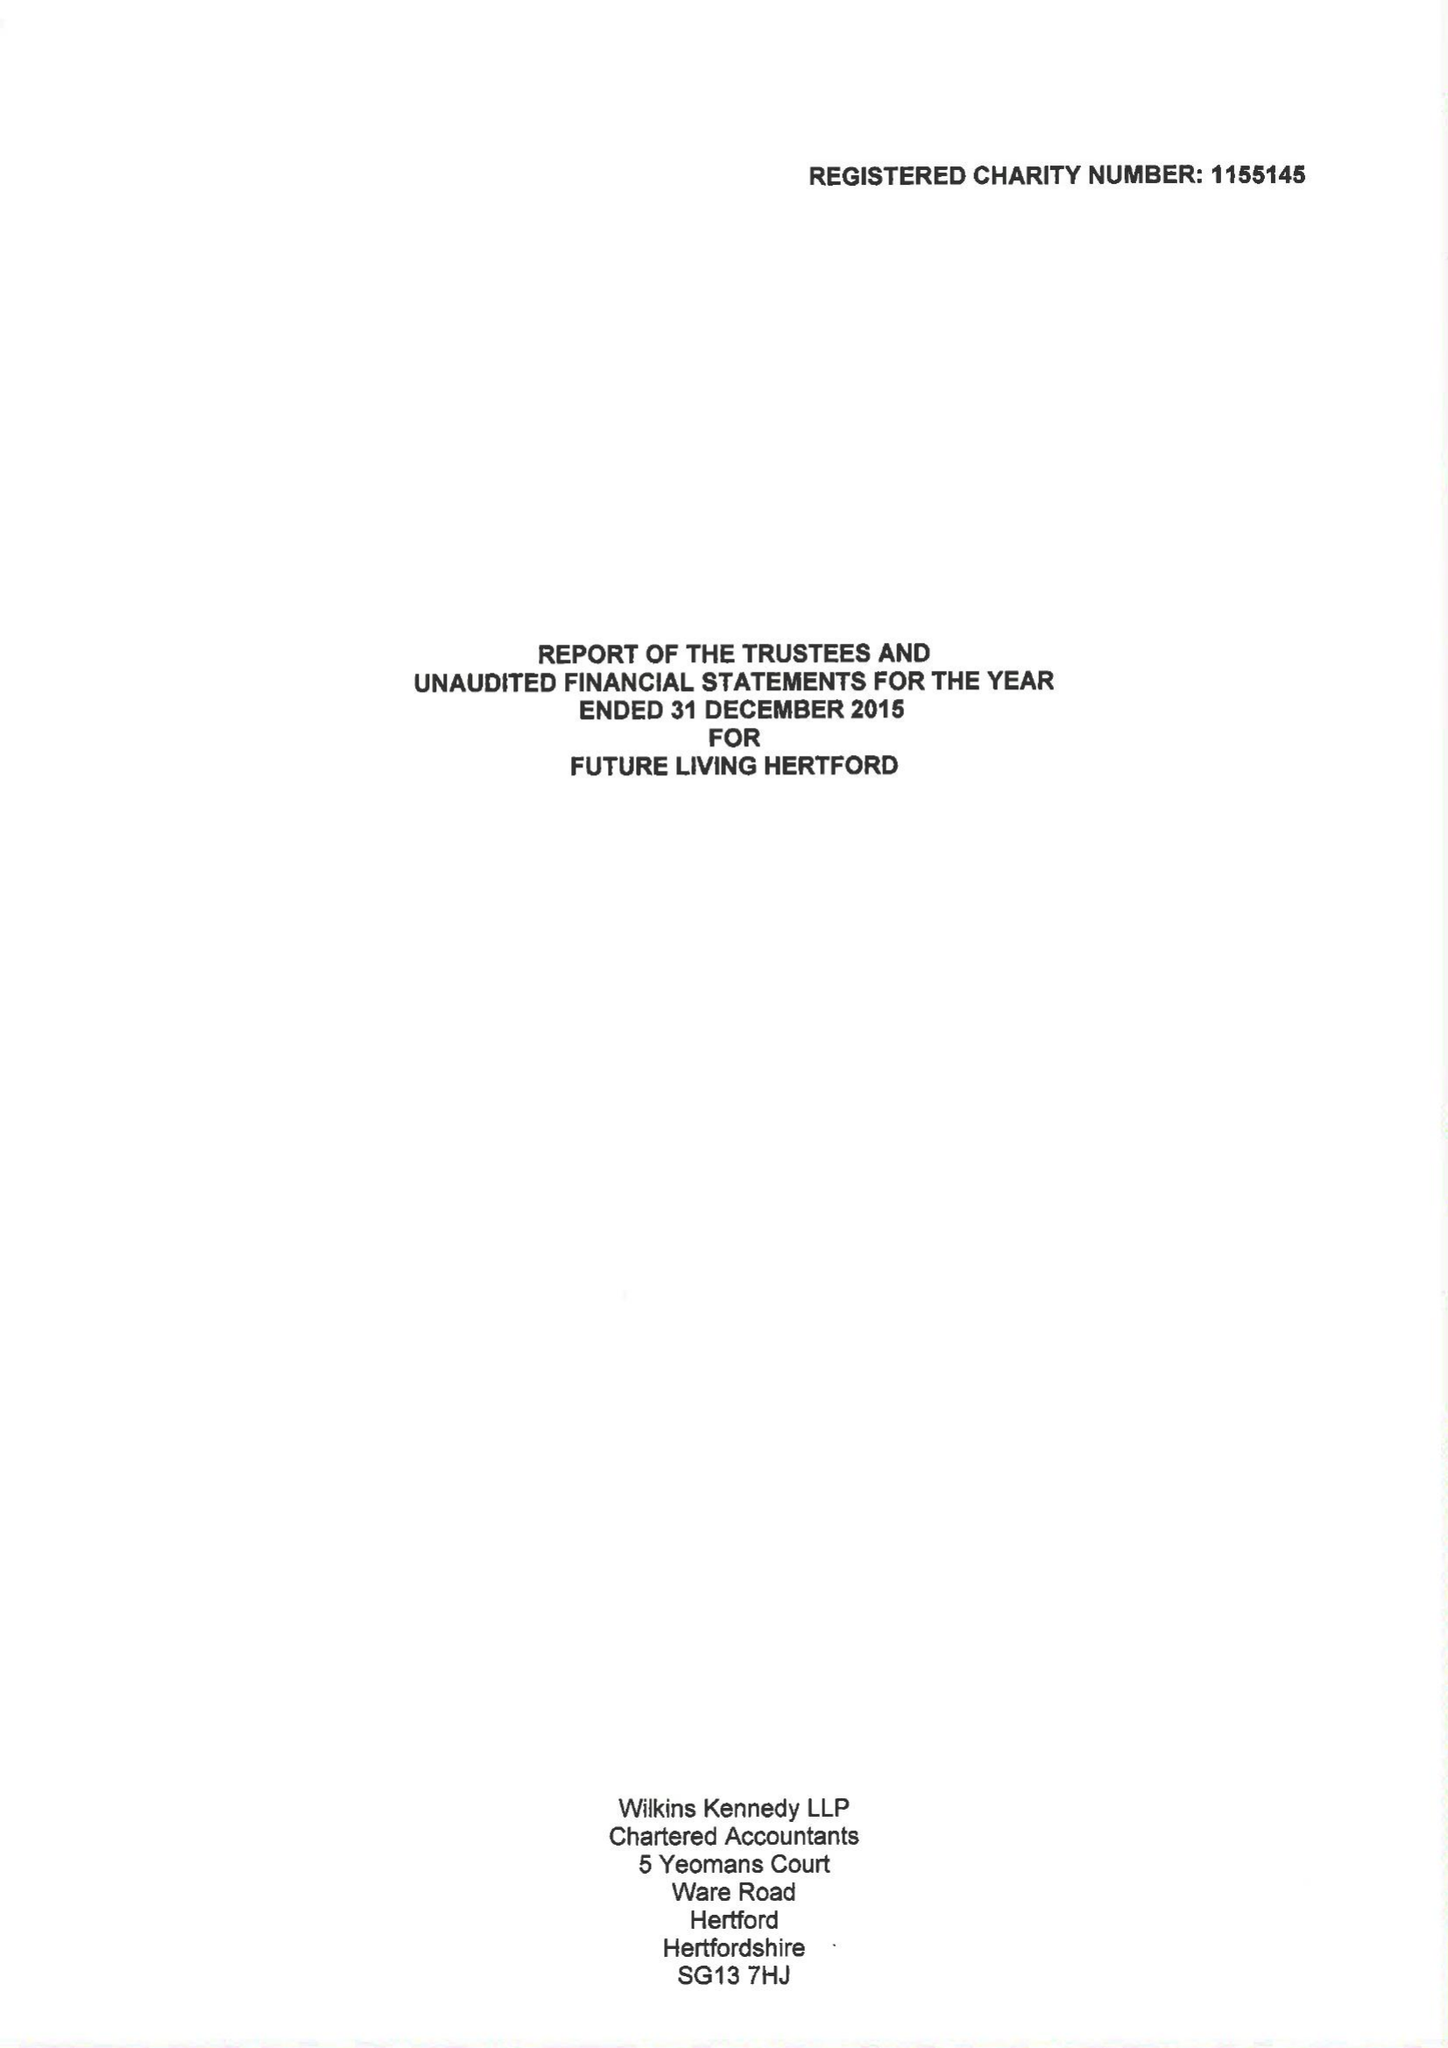What is the value for the spending_annually_in_british_pounds?
Answer the question using a single word or phrase. 70328.00 